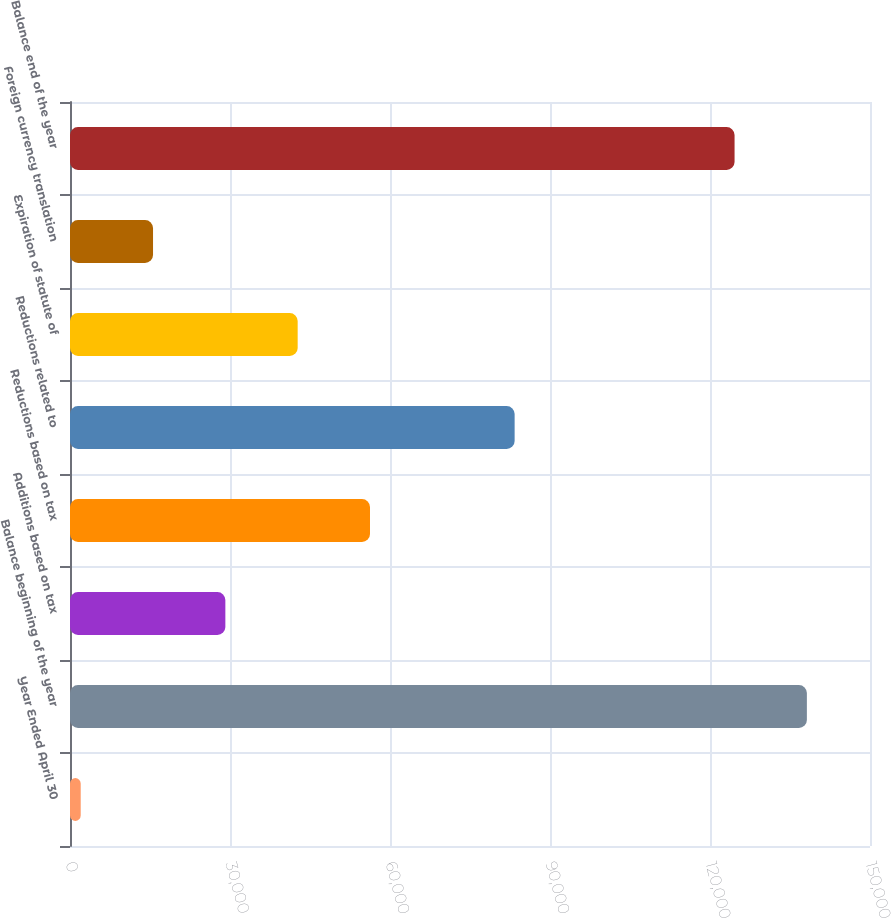<chart> <loc_0><loc_0><loc_500><loc_500><bar_chart><fcel>Year Ended April 30<fcel>Balance beginning of the year<fcel>Additions based on tax<fcel>Reductions based on tax<fcel>Reductions related to<fcel>Expiration of statute of<fcel>Foreign currency translation<fcel>Balance end of the year<nl><fcel>2009<fcel>138165<fcel>29128.8<fcel>56248.6<fcel>83368.4<fcel>42688.7<fcel>15568.9<fcel>124605<nl></chart> 